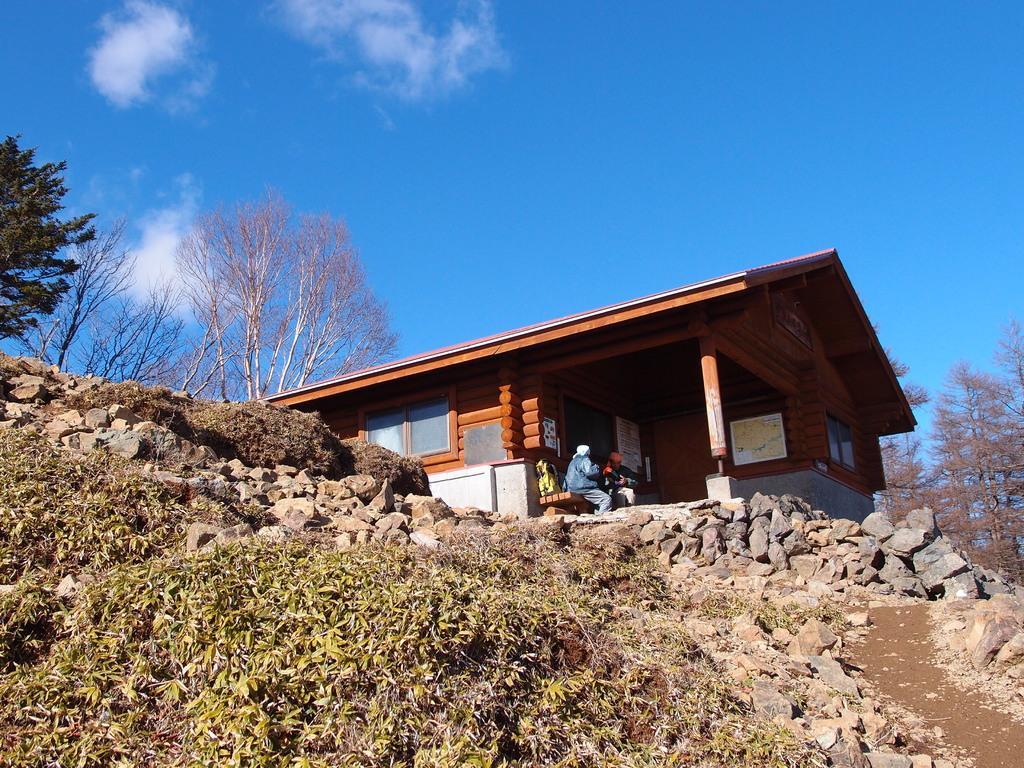Describe this image in one or two sentences. In this image we can see the wooden house, trees, grass and also the stones. At the top we can see the sky with the clouds. We can also see two persons sitting on the bench. 